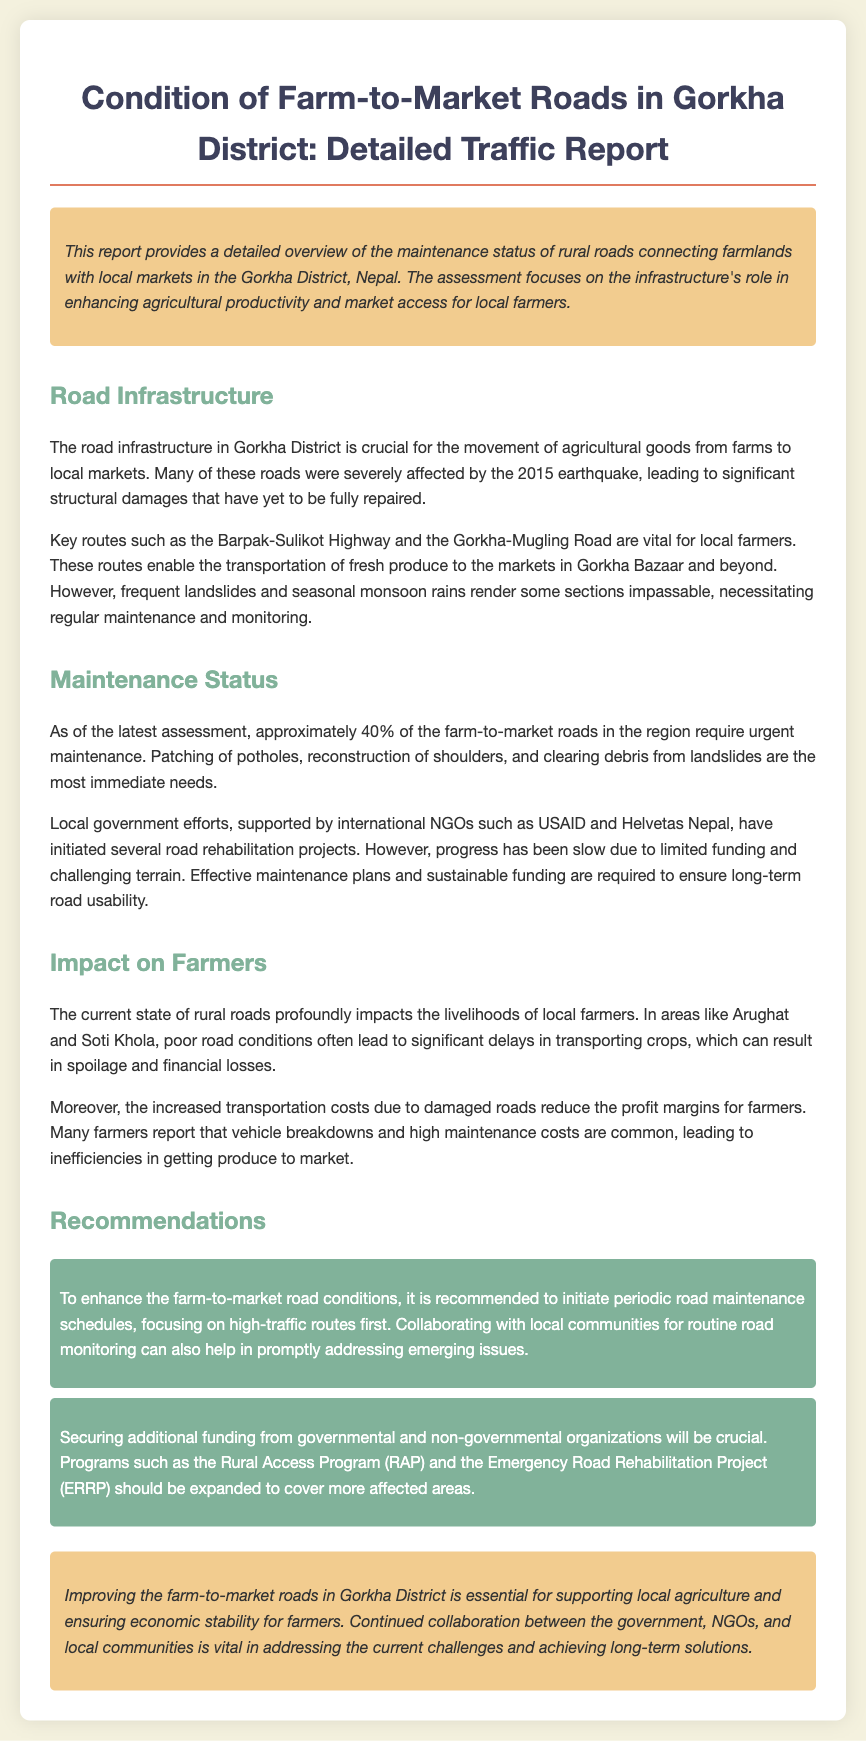what percentage of farm-to-market roads require urgent maintenance? The document states that approximately 40% of the farm-to-market roads in the region require urgent maintenance.
Answer: 40% which organizations are supporting local government efforts for road rehabilitation? The document mentions international NGOs such as USAID and Helvetas Nepal supporting local government efforts.
Answer: USAID and Helvetas Nepal what is the impact of poor road conditions on local farmers? The document indicates that poor road conditions often lead to significant delays in transporting crops, resulting in spoilage and financial losses.
Answer: Spoilage and financial losses what types of maintenance are urgently needed on the roads? According to the report, patching of potholes, reconstruction of shoulders, and clearing debris from landslides are the most immediate needs.
Answer: Patching potholes, reconstruction of shoulders, clearing debris what is recommended for enhancing farm-to-market road conditions? The document recommends initiating periodic road maintenance schedules and collaborating with local communities for routine road monitoring.
Answer: Periodic maintenance schedules and community collaboration 